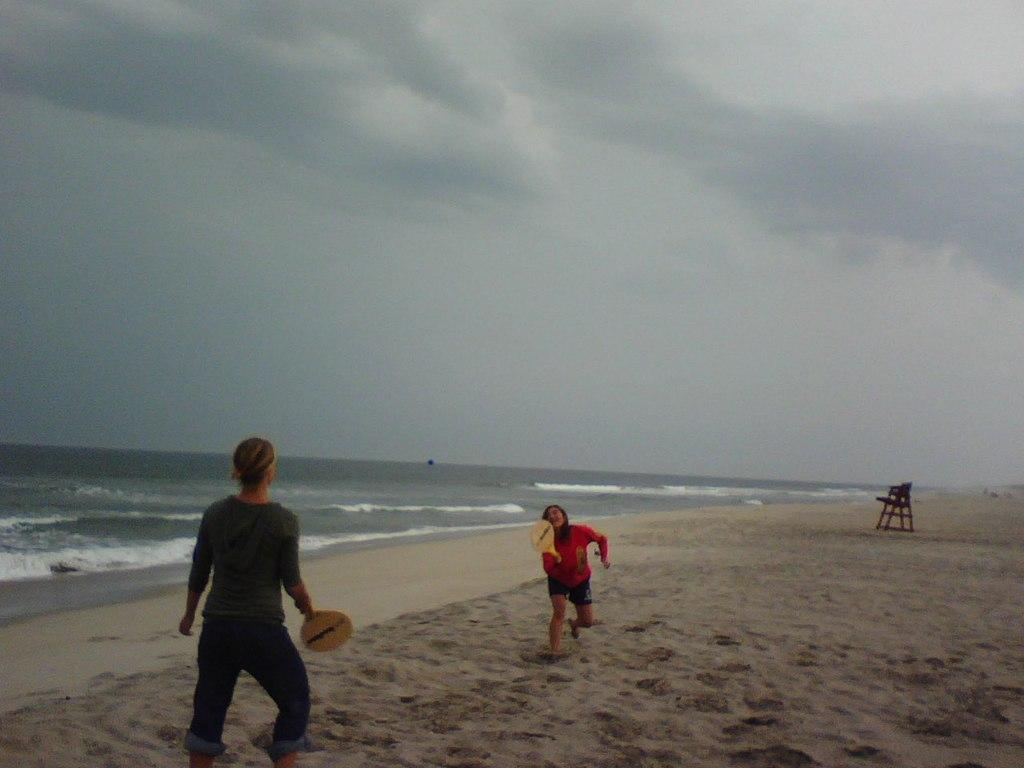Can you describe this image briefly? In this image I can see at the bottom it looks like two persons are playing the game, they are wearing the t-shirts. On the right side it may be the wooden chair and in the background there is water. at the top there is the sky, at the bottom there is the sand. 